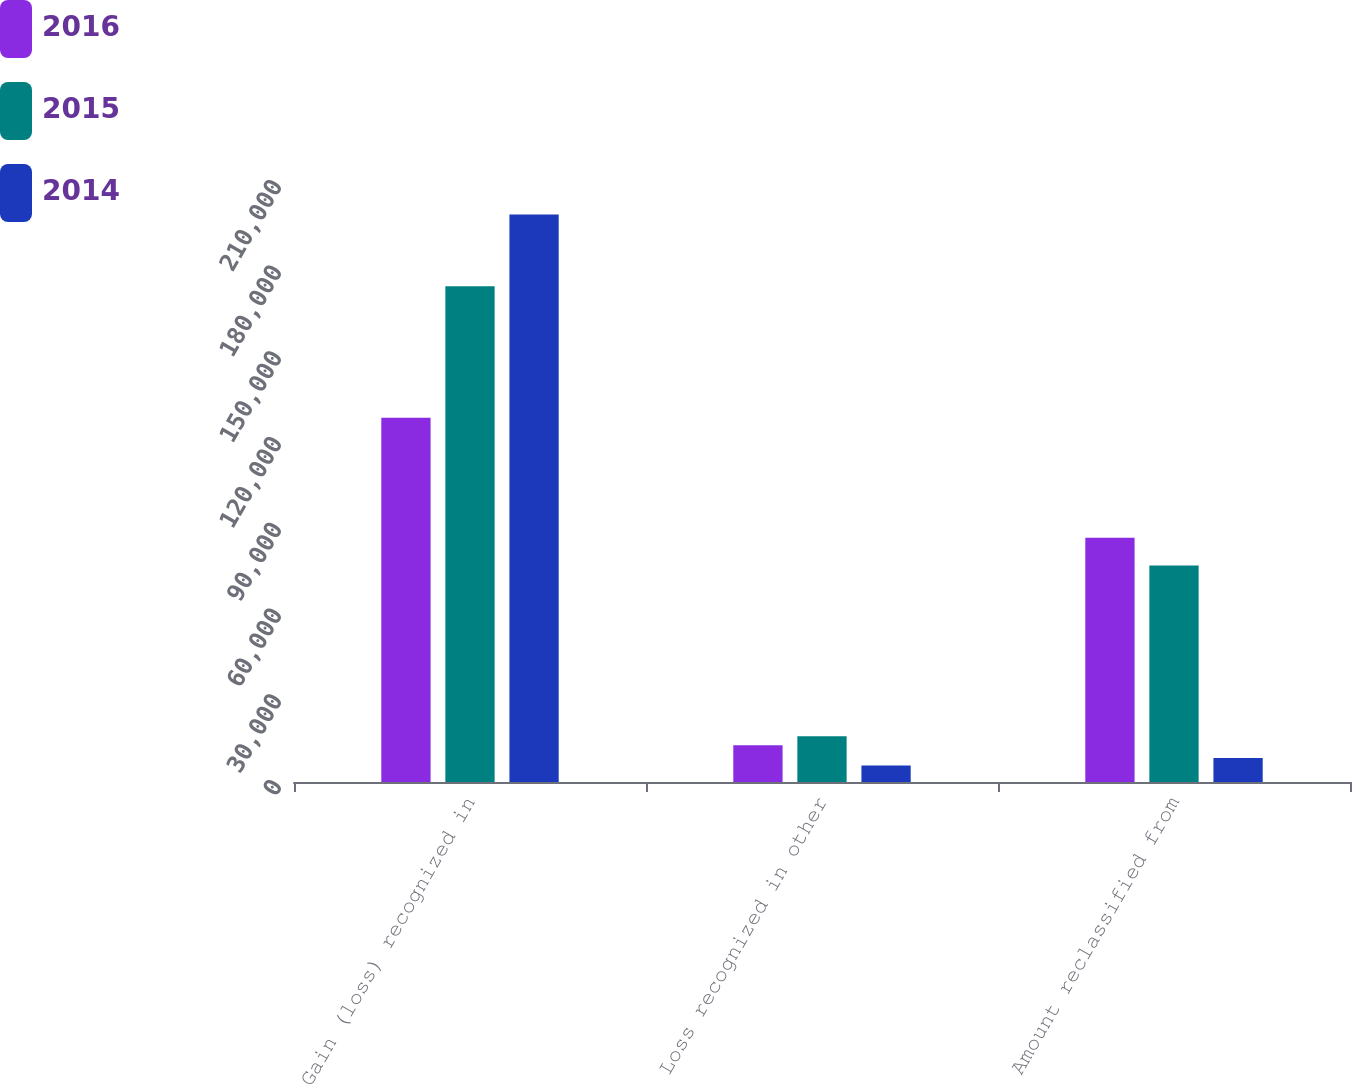Convert chart to OTSL. <chart><loc_0><loc_0><loc_500><loc_500><stacked_bar_chart><ecel><fcel>Gain (loss) recognized in<fcel>Loss recognized in other<fcel>Amount reclassified from<nl><fcel>2016<fcel>127470<fcel>12850<fcel>85448<nl><fcel>2015<fcel>173513<fcel>16011<fcel>75808<nl><fcel>2014<fcel>198595<fcel>5753<fcel>8388<nl></chart> 